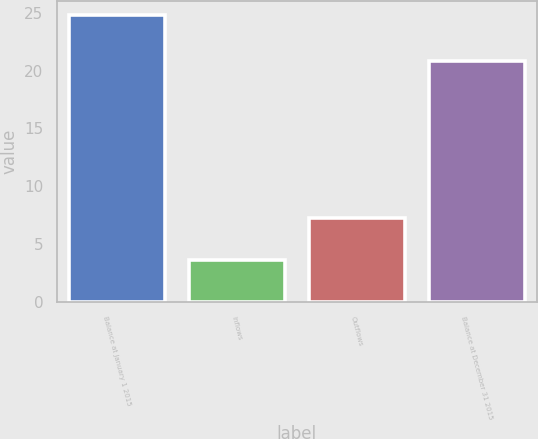<chart> <loc_0><loc_0><loc_500><loc_500><bar_chart><fcel>Balance at January 1 2015<fcel>Inflows<fcel>Outflows<fcel>Balance at December 31 2015<nl><fcel>24.8<fcel>3.6<fcel>7.3<fcel>20.8<nl></chart> 